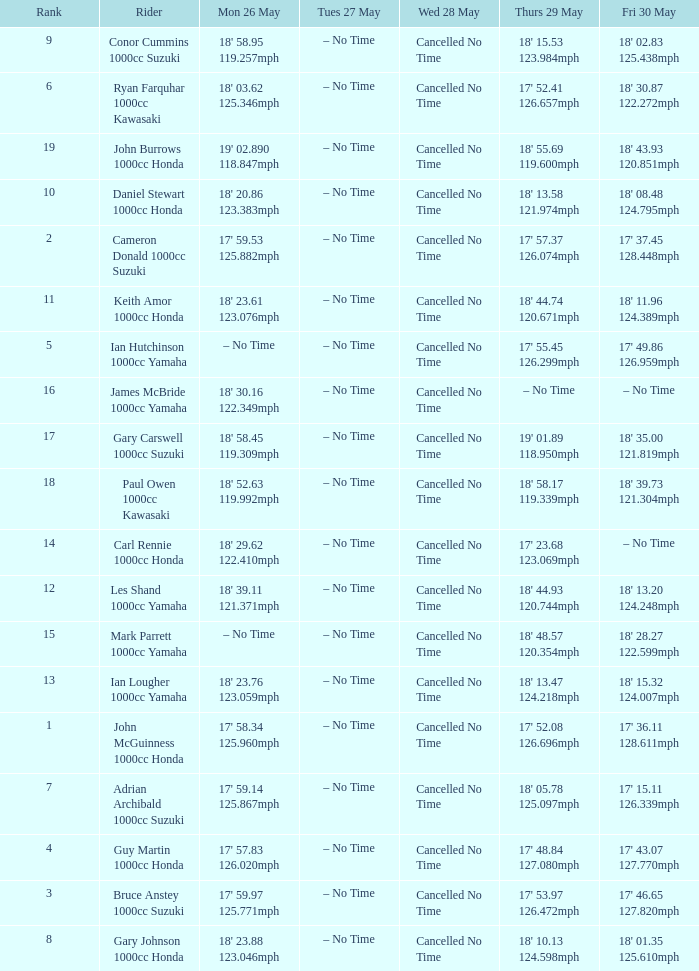What time is mon may 26 and fri may 30 is 18' 28.27 122.599mph? – No Time. 